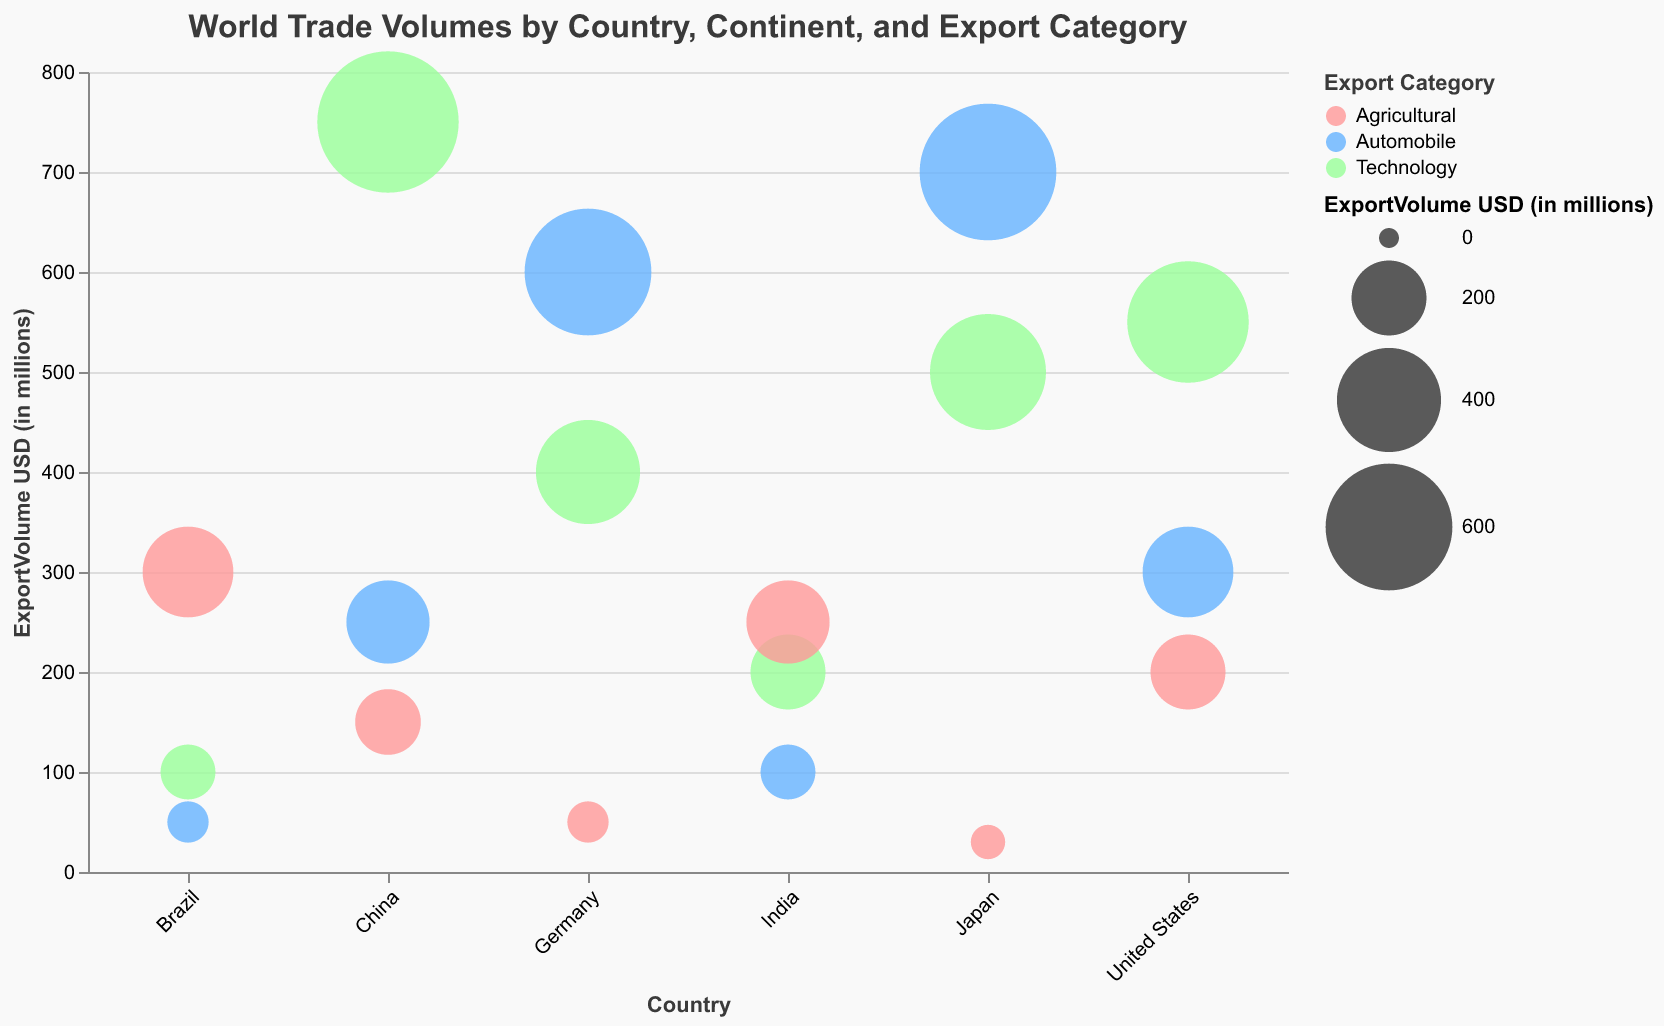What's the title of the figure? The title is generally located at the top center of the figure and typically describes the content and purpose of the chart. In this case, it states "World Trade Volumes by Country, Continent, and Export Category".
Answer: World Trade Volumes by Country, Continent, and Export Category How do the export volumes for Agricultural products compare between the United States and India? To compare, look at the bubbles for Agricultural products for both countries. The United States has an Agricultural export volume of 200 million USD, and India has 250 million USD.
Answer: India exports more Agricultural products than the United States What is the most exported category from Japan? Identify the largest bubble for Japan, which represents the highest export volume. The largest bubble for Japan corresponds to the Automobile category with 700 million USD.
Answer: Automobile Which country has the smallest export volume in the Agricultural category? Search for the smallest bubble within the Agricultural category across all countries. Germany has the smallest bubble, indicating 50 million USD.
Answer: Germany How does the transparency level affect the visibility of the bubbles? Transparency levels range from 0 (fully transparent) to 1 (fully opaque). Higher transparency levels make the bubbles more see-through, which can affect their visibility and make it easier to see overlapping bubbles. For example, Agricultural exports from Brazil have a transparency level of 0.6, making the bubble partially transparent.
Answer: Higher transparency makes bubbles more see-through What are the three main export categories represented by different colors? The figure uses color to distinguish between export categories. Identify the colors and their corresponding legends, which are Technology (light red), Automobile (light blue), and Agricultural (light green).
Answer: Technology, Automobile, Agricultural Which country in South America exports the most Technology products? Look at the bubbles for Technology in South America. Brazil is the only South American country in the chart and exports 100 million USD in Technology products.
Answer: Brazil Is there any continent that appears to dominate a particular export category? Assess the bubbles for export categories across continents. Asia dominates Technology exports with significant contributions from China (750 million USD) and Japan (500 million USD).
Answer: Asia What's the total export volume for Agricultural products across all countries? Sum the export volumes for Agricultural products: 200 (US) + 150 (China) + 50 (Germany) + 300 (Brazil) + 30 (Japan) + 250 (India) = 980 million USD.
Answer: 980 million USD Does the size of the bubble correlate with the export volume? Yes, the bubble size directly correlates to the export volume, with larger bubbles representing higher export volumes, as seen with Technology exports from China (750 million USD, the largest bubble).
Answer: Yes, it correlates 